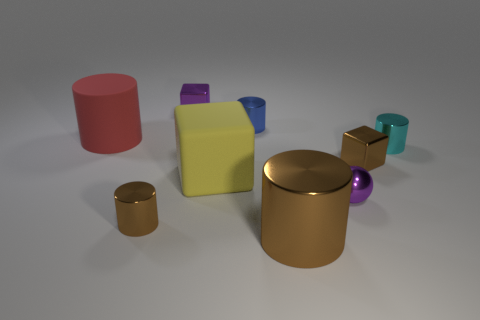Subtract 1 purple balls. How many objects are left? 8 Subtract all spheres. How many objects are left? 8 Subtract 1 blocks. How many blocks are left? 2 Subtract all brown balls. Subtract all purple cylinders. How many balls are left? 1 Subtract all cyan cylinders. How many gray blocks are left? 0 Subtract all cyan cylinders. Subtract all small brown objects. How many objects are left? 6 Add 5 purple metal cubes. How many purple metal cubes are left? 6 Add 2 gray matte cubes. How many gray matte cubes exist? 2 Subtract all purple cubes. How many cubes are left? 2 Subtract all small blue cylinders. How many cylinders are left? 4 